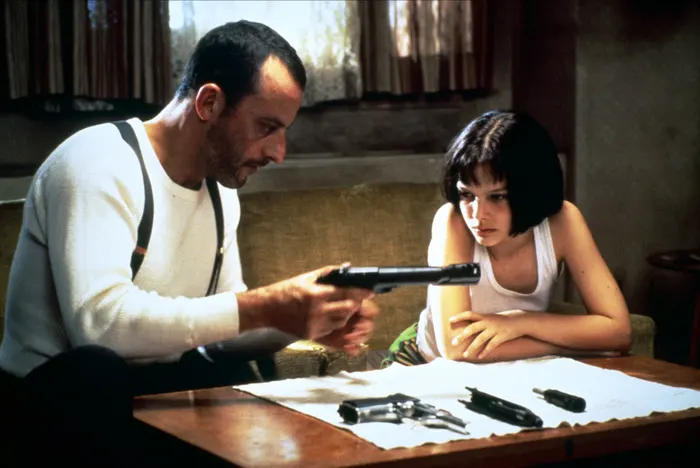Imagine the next scene after this. What happens? In the next scene, Léon might continue to guide Mathilda through more intricate aspects of handling firearms, perhaps setting up a practice target for her. Mathilda's determination continues to build as she becomes more adept under Léon's tutelage. As they progress, there could be a brief, candid conversation where Mathilda expresses her gratitude and shares more about her past, adding layers to their dynamic and setting up the emotional stakes for future events in the story. 